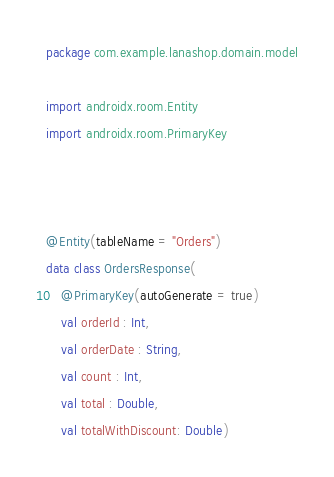Convert code to text. <code><loc_0><loc_0><loc_500><loc_500><_Kotlin_>package com.example.lanashop.domain.model

import androidx.room.Entity
import androidx.room.PrimaryKey



@Entity(tableName = "Orders")
data class OrdersResponse(
    @PrimaryKey(autoGenerate = true)
    val orderId : Int,
    val orderDate : String,
    val count : Int,
    val total : Double,
    val totalWithDiscount: Double)


</code> 